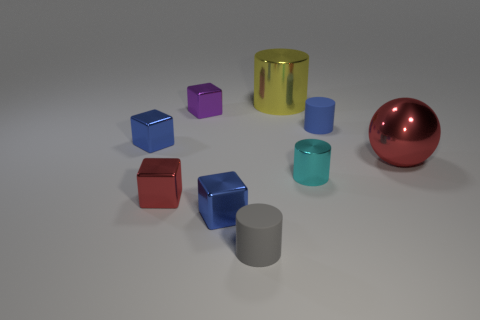Subtract all purple shiny cubes. How many cubes are left? 3 Subtract all red balls. How many blue cubes are left? 2 Subtract all purple blocks. How many blocks are left? 3 Subtract 1 cylinders. How many cylinders are left? 3 Add 1 blue things. How many objects exist? 10 Subtract all brown cylinders. Subtract all green balls. How many cylinders are left? 4 Subtract all spheres. How many objects are left? 8 Subtract all small purple metal blocks. Subtract all tiny cyan shiny objects. How many objects are left? 7 Add 5 small blue matte objects. How many small blue matte objects are left? 6 Add 4 tiny green blocks. How many tiny green blocks exist? 4 